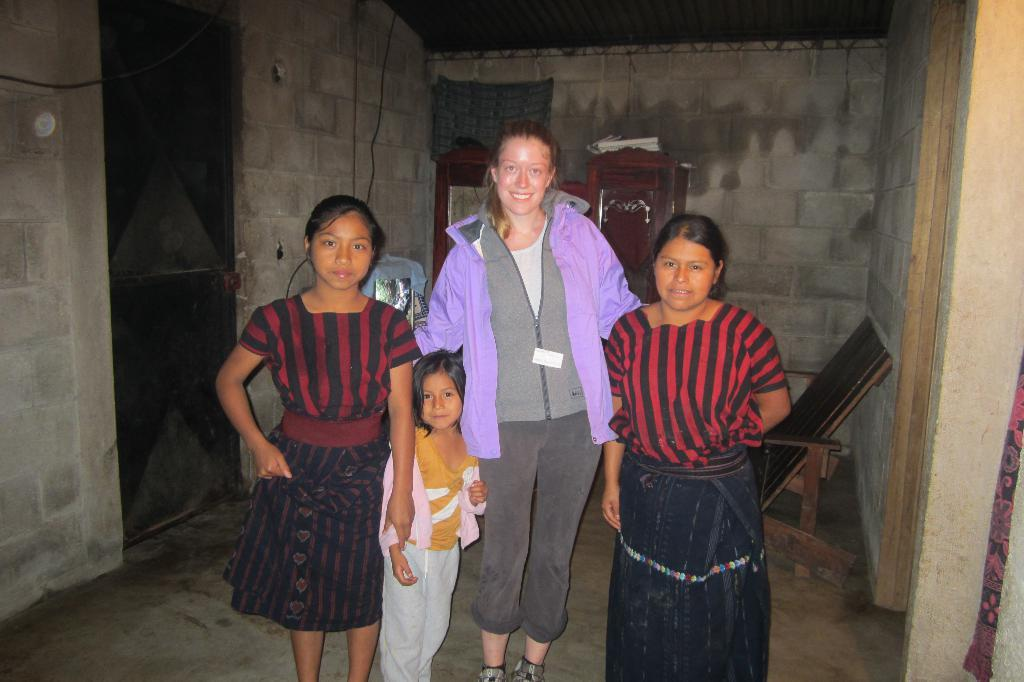How many people are present in the image? There are four people in the image. Can you describe the gender of the people? Two of the people are girls. What are the girls wearing? The girls are wearing skirts. What can be seen in the background of the image? There is a chair, a door, and a wall in the image. What is the purpose of the dirt in the image? There is no dirt present in the image, so it cannot serve any purpose within the context of the image. 